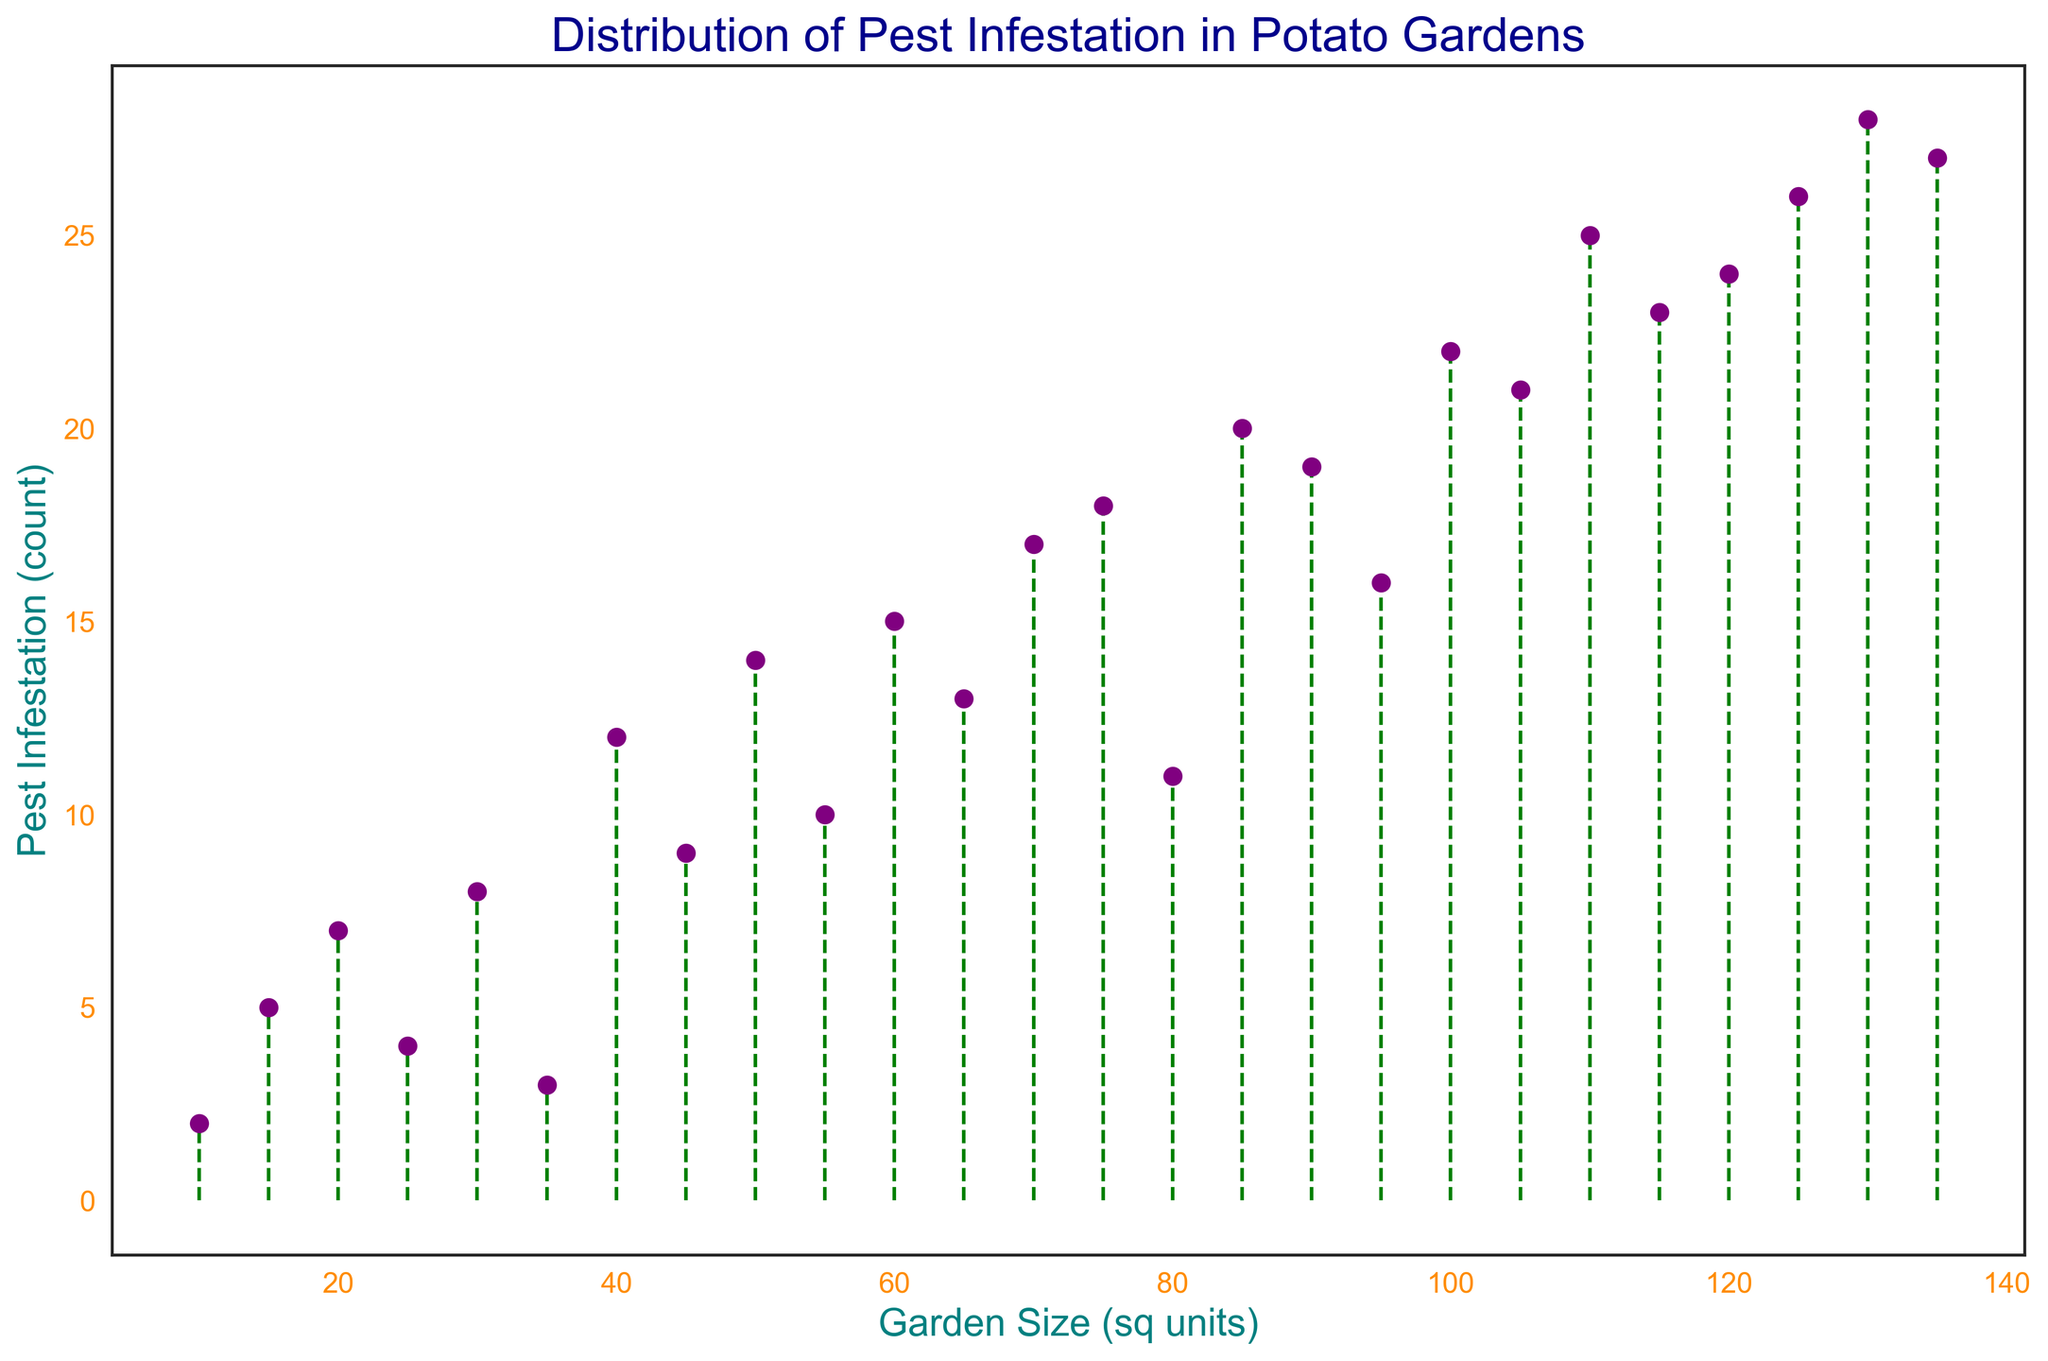What is the garden size corresponding to the highest pest infestation? The highest pest infestation count in the figure is 28. By locating this count on the y-axis and tracing it to the corresponding garden size on the x-axis, we find that the garden size is 130.
Answer: 130 Which garden size has a higher pest infestation: 50 sq units or 80 sq units? Look at the pest infestation counts for garden sizes 50 and 80 on the x-axis. The count for 50 sq units is 14, and for 80 sq units, it is 11. Since 14 is greater than 11, the garden size of 50 sq units has a higher pest infestation.
Answer: 50 What is the average pest infestation for gardens of sizes 40, 60, and 100 sq units? The pest infestations for garden sizes 40, 60, and 100 are 12, 15, and 22, respectively. The sum of these values is 12 + 15 + 22 = 49. The average is 49/3 = 16.33.
Answer: 16.33 Is there a trend between garden size and pest infestation? By observing the plot, there is a general upward trend indicating that larger garden sizes tend to have higher pest infestations, although there are some fluctuations.
Answer: Yes Which has more variability in pest infestation: gardens smaller than 50 sq units or larger than 50 sq units? Calculate the range for both categories. For gardens smaller than 50 sq units, infestations range from 2 to 12, so variability is 12-2=10. For gardens larger than 50 sq units, infestations range from 13 to 28, so variability is 28-13=15. Therefore, the larger gardens have more variability.
Answer: Larger gardens What is the difference in pest infestation between the smallest and largest garden sizes? The smallest garden size is 10 sq units with a pest infestation of 2, and the largest garden size is 135 sq units with a pest infestation of 27. The difference is 27 - 2 = 25.
Answer: 25 Does the stem plot use color to differentiate between different levels of pest infestation? The plot uses purple markers and green dashed lines, but these visual attributes are not specific to different levels of pest infestation; they are uniform across all data points.
Answer: No At which garden size does the pest infestation first reach a count of 20? By tracing the first occurrence of pest infestation reaching 20, we find that it corresponds to the garden size of 85 sq units.
Answer: 85 Which garden size has the lowest pest infestation, and what is the count? The lowest number of pest infestations is 2, and it occurs at the garden size of 10 sq units.
Answer: 10 What is the shape of the plot, and what does it indicate about the distribution of data points? The plot is generally upward-sloping but with several small fluctuating peaks and troughs. This indicates that while there is a trend towards higher pest infestations with increased garden size, the data does not follow a perfectly linear pattern and has some variability.
Answer: Upward-sloping with fluctuations 